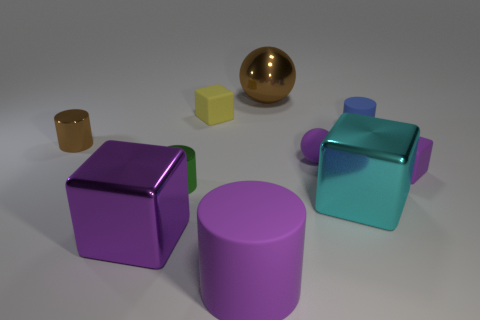What number of big objects are purple shiny cubes or blue matte things?
Keep it short and to the point. 1. The small matte cylinder is what color?
Give a very brief answer. Blue. There is a brown thing that is to the right of the block that is in front of the cyan metal cube; what is its shape?
Provide a succinct answer. Sphere. Are there any purple cubes that have the same material as the cyan cube?
Make the answer very short. Yes. Is the size of the brown metallic object in front of the yellow thing the same as the tiny purple cube?
Your answer should be very brief. Yes. How many yellow things are either small balls or tiny things?
Your response must be concise. 1. There is a purple thing to the left of the purple cylinder; what is its material?
Provide a succinct answer. Metal. What number of big cylinders are behind the matte cylinder behind the purple metal thing?
Give a very brief answer. 0. What number of other green shiny things have the same shape as the small green object?
Keep it short and to the point. 0. How many gray metal cylinders are there?
Provide a succinct answer. 0. 